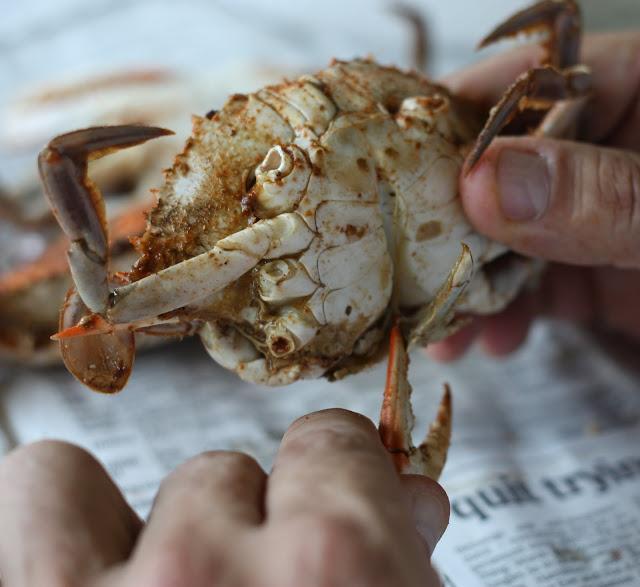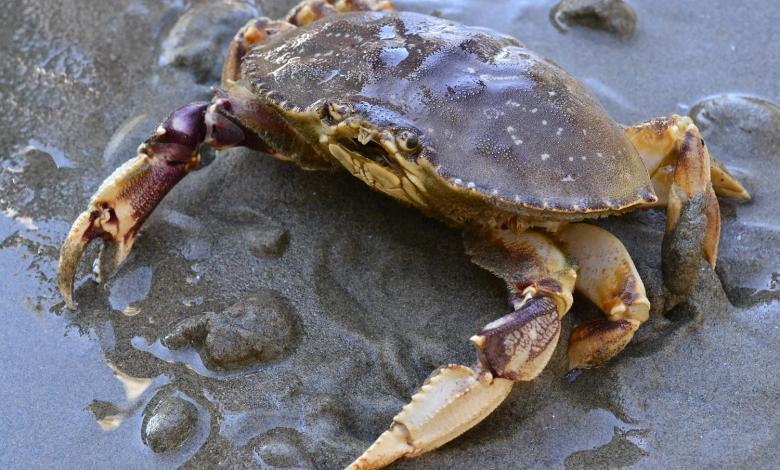The first image is the image on the left, the second image is the image on the right. Analyze the images presented: Is the assertion "A person is touching the crab in the image on the left." valid? Answer yes or no. Yes. The first image is the image on the left, the second image is the image on the right. Given the left and right images, does the statement "Two hands are holding the crab in the left image." hold true? Answer yes or no. Yes. 